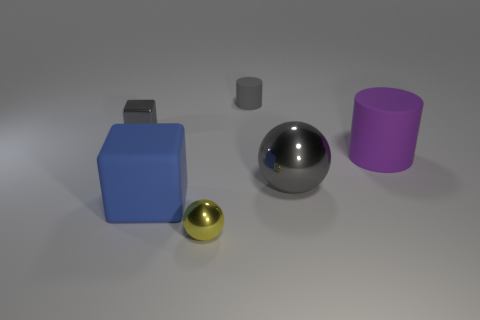Add 2 large purple rubber objects. How many objects exist? 8 Subtract all balls. How many objects are left? 4 Add 3 big gray balls. How many big gray balls exist? 4 Subtract 1 yellow spheres. How many objects are left? 5 Subtract all big purple shiny cylinders. Subtract all small yellow objects. How many objects are left? 5 Add 3 big purple matte cylinders. How many big purple matte cylinders are left? 4 